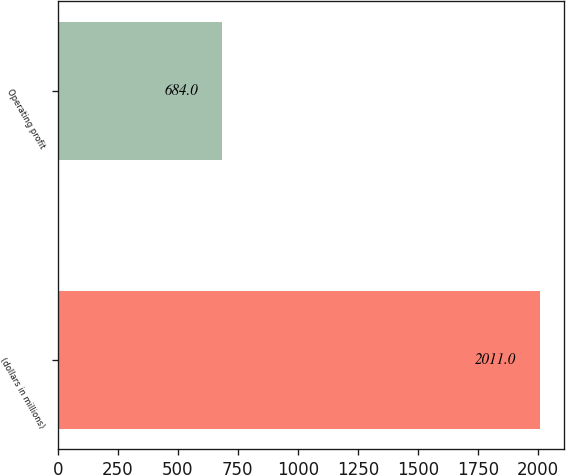<chart> <loc_0><loc_0><loc_500><loc_500><bar_chart><fcel>(dollars in millions)<fcel>Operating profit<nl><fcel>2011<fcel>684<nl></chart> 